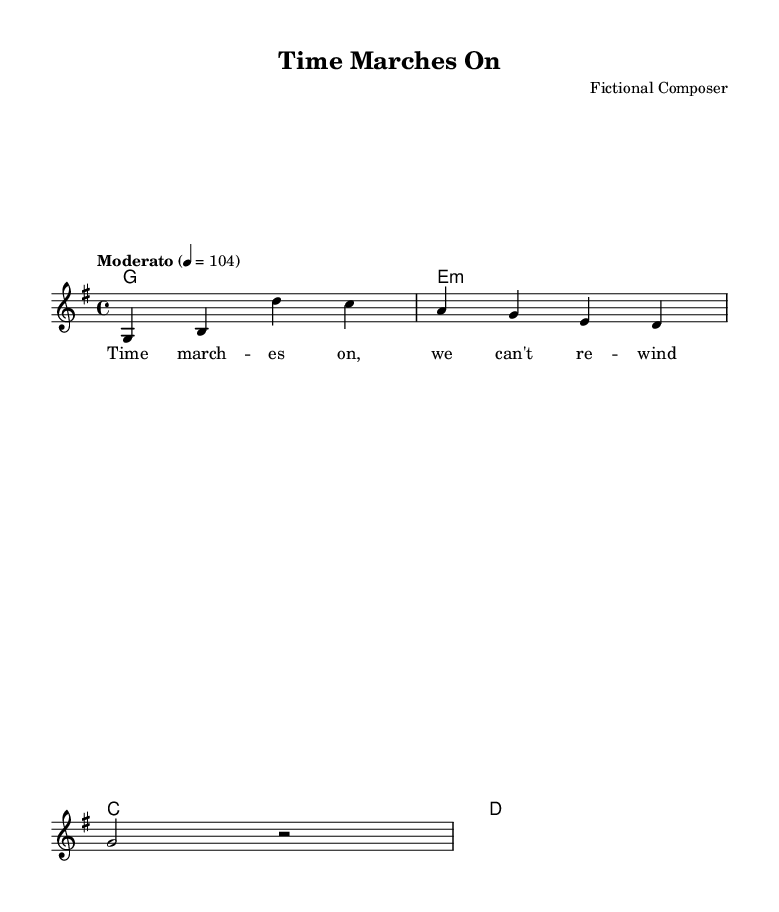What is the key signature of this music? The key signature indicated in the sheet music is G major, which has one sharp (F#). This can be inferred from the global section where the key is stated.
Answer: G major What is the time signature of this music? The time signature shown in the sheet music is 4/4, which is mentioned in the global section. This indicates that there are four beats in each measure and the quarter note gets one beat.
Answer: 4/4 What is the tempo marking of this music? The tempo marking in the music sheet is "Moderato," set at a speed of 104 beats per minute. This is specified in the global section, providing a feel for the pace of the piece.
Answer: Moderato How many measures are present in this melody? The melody contains four measures, as noted in the melody section where each line corresponds to a measure in the music.
Answer: 4 What is the first note of the melody? The first note of the melody is G. This is indicated at the beginning of the melody line, where the first pitch is notated.
Answer: G What chords are used in the harmonies? The harmonies consist of the chords G, E minor, C, and D as indicated in the chord mode section. These chords define the harmonic structure accompanying the melody.
Answer: G, E minor, C, D What is the theme expressed in the lyrics? The theme expressed in the lyrics "Time marches on, we can't rewind" reflects the concept of the inevitability of aging. This can be seen from the lyrical content provided in the verse section.
Answer: Time marches on 